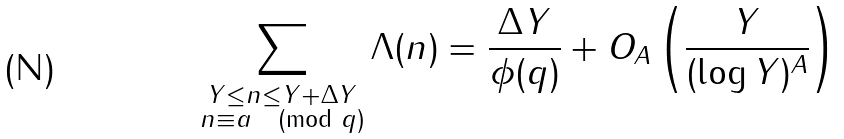Convert formula to latex. <formula><loc_0><loc_0><loc_500><loc_500>\sum _ { \substack { Y \leq n \leq Y + \Delta Y \\ n \equiv a \pmod { q } } } \Lambda ( n ) = \frac { \Delta Y } { \phi ( q ) } + O _ { A } \left ( \frac { Y } { ( \log { Y } ) ^ { A } } \right )</formula> 